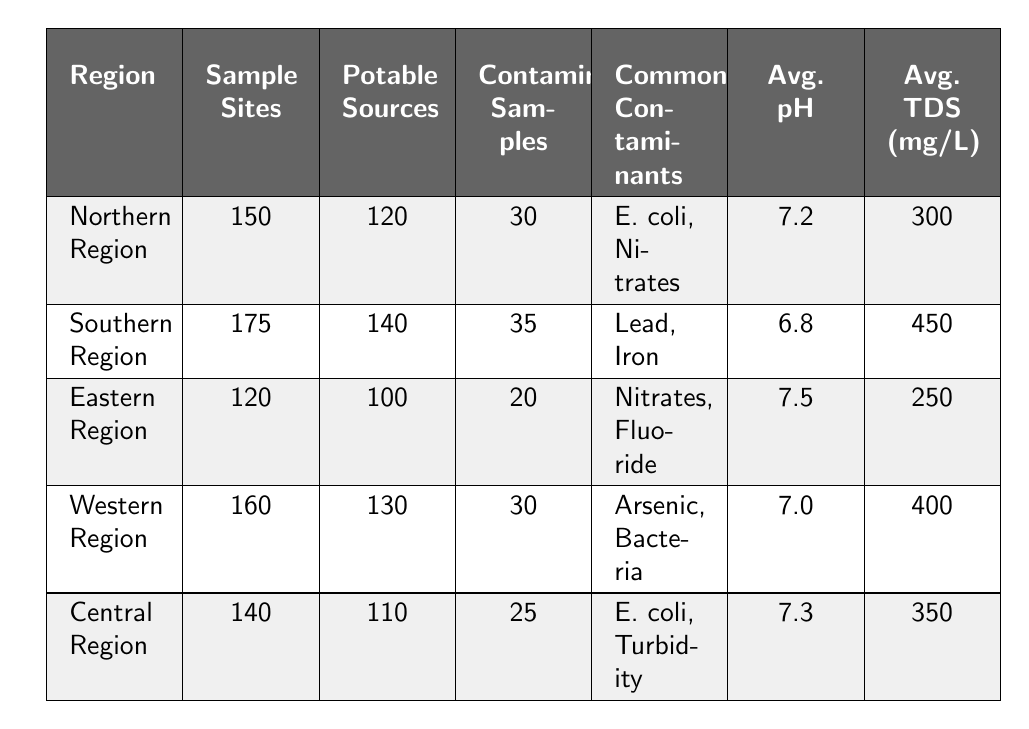What is the region with the highest number of sample sites? The table lists the number of sample sites for each region. The Southern Region has 175 sample sites, which is more than any other region.
Answer: Southern Region How many total potable water sources are reported across all regions? To find the total, add the potable water sources from each region: 120 + 140 + 100 + 130 + 110 = 700.
Answer: 700 Which region reports the lowest average total dissolved solids? The average total dissolved solids values are: Northern Region (300), Southern Region (450), Eastern Region (250), Western Region (400), and Central Region (350). The Eastern Region has the lowest at 250 mg/L.
Answer: Eastern Region Is there any region with more than 30 contaminated samples? The Southern Region (35) and the Southern Region (35) both have more than 30 contaminated samples.
Answer: Yes What is the difference in average pH between the Northern Region and the Southern Region? The average pH for the Northern Region is 7.2 and for the Southern Region is 6.8. The difference is calculated as 7.2 - 6.8 = 0.4.
Answer: 0.4 Which contaminants are reported in both the Northern Region and the Central Region? The Northern Region lists E. coli and Nitrates, while the Central Region lists E. coli and Turbidity. The common contaminant between both is E. coli.
Answer: E. coli What is the average number of contaminated samples across all regions? The contaminated samples for each region are: 30 (Northern) + 35 (Southern) + 20 (Eastern) + 30 (Western) + 25 (Central) = 170. To find the average, divide by 5 regions: 170 / 5 = 34.
Answer: 34 Which region has the highest percentage of potable water sources? Calculate the percentage of potable sources for each region. For Northern Region: (120 / 150) × 100 = 80%, Southern Region: (140 / 175) × 100 = 80%, Eastern Region: (100 / 120) × 100 = 83.3%, Western Region: (130 / 160) × 100 = 81.25%, Central Region: (110 / 140) × 100 = 78.57%. The Eastern Region has the highest at 83.3%.
Answer: Eastern Region Which region should be prioritized for intervention based on the number of contaminated samples? The Southern Region has the highest number of contaminated samples at 35 and should be prioritized for intervention.
Answer: Southern Region Are there any regions where the average pH is below 7.0? The Southern Region has an average pH of 6.8, which is below 7.0. The other regions have pH values above 7.0.
Answer: Yes 